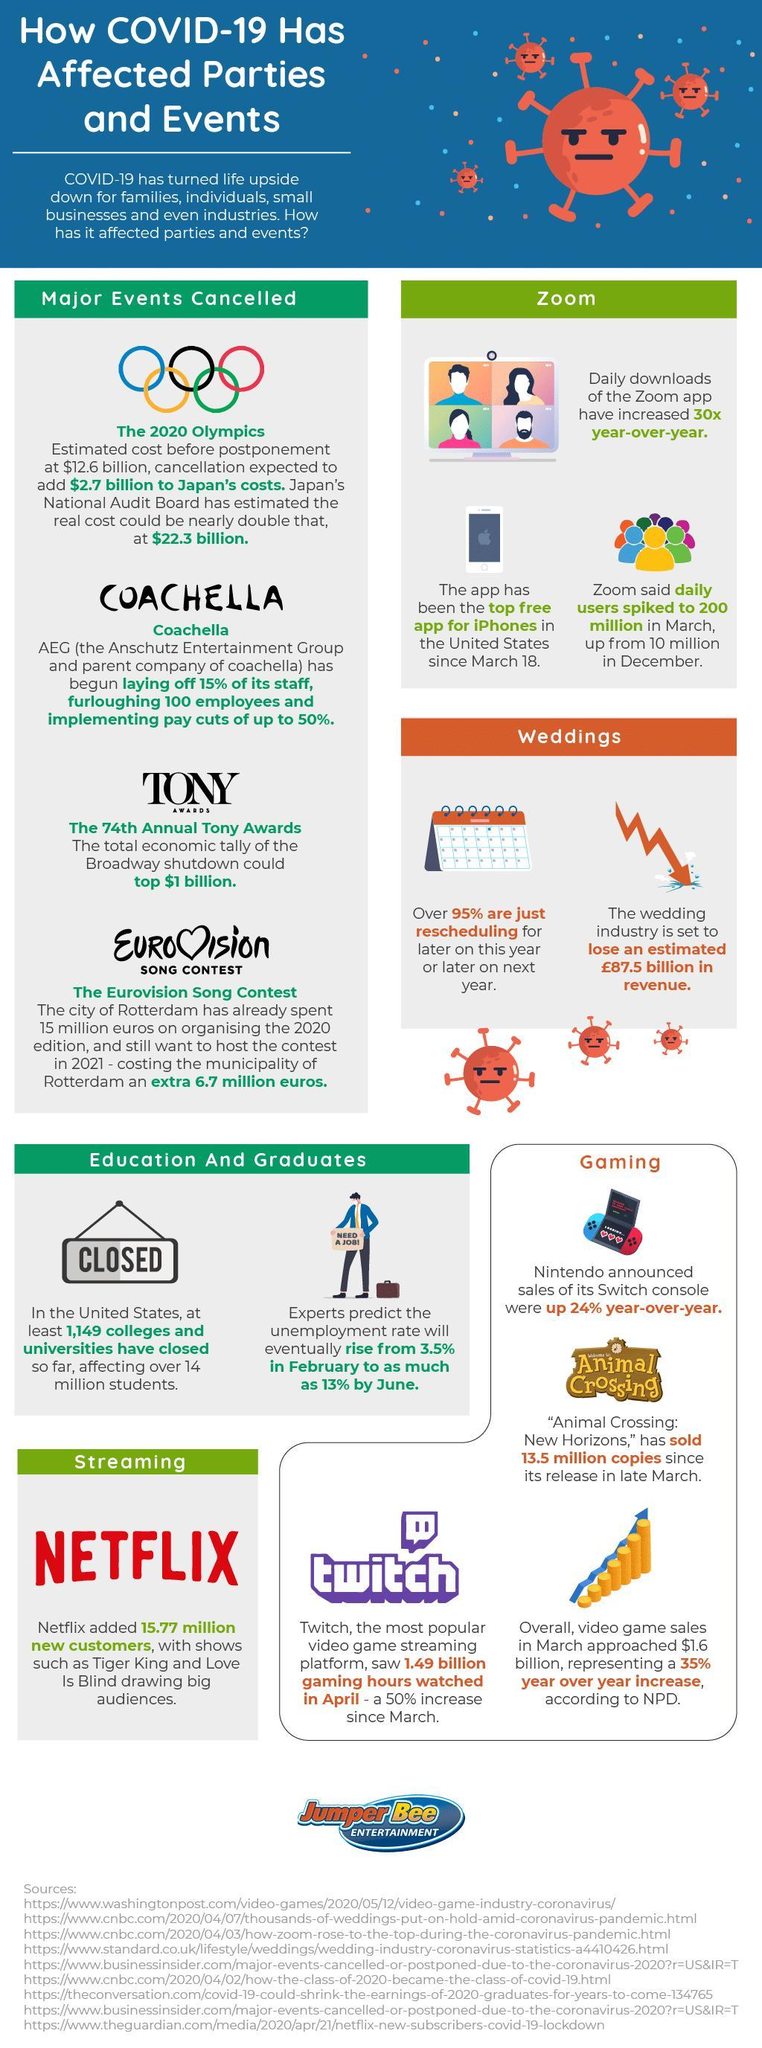How many sources are listed?
Answer the question with a short phrase. 9 